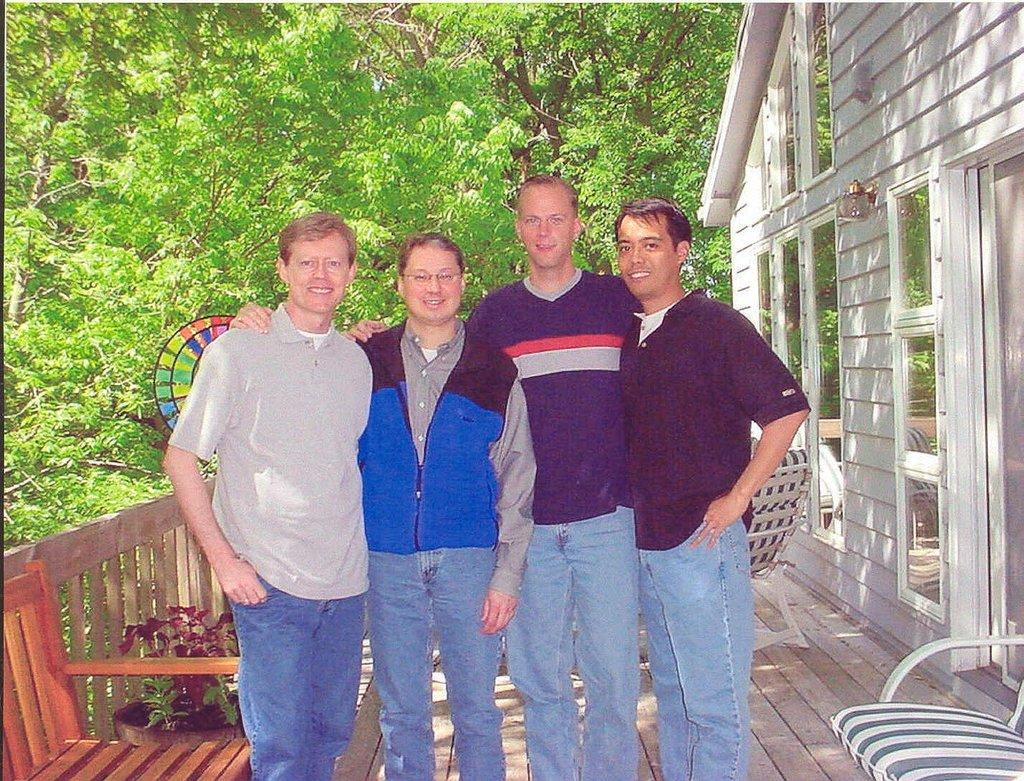How many people are in the image? There are people in the image, but the exact number is not specified. What is the fence made of in the image? The material of the fence is not mentioned in the facts. What type of seating is available in the image? There are chairs in the image. What type of building is visible in the image? There is a house in the image. What kind of plant is present in the image? There is a plant in the image. What can be seen in the distance in the image? Trees are visible in the background of the image. What type of cable is being used to support the plant in the image? There is no mention of a cable supporting the plant in the image. The plant is simply present, and its support system is not described. 